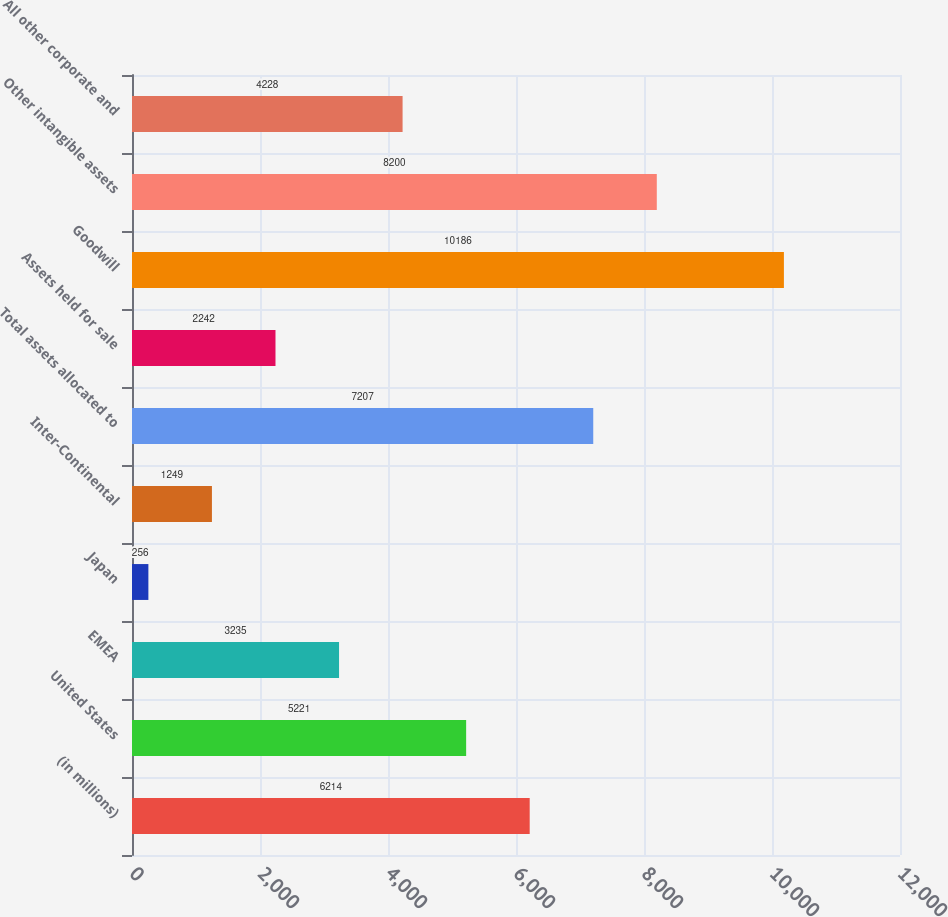Convert chart to OTSL. <chart><loc_0><loc_0><loc_500><loc_500><bar_chart><fcel>(in millions)<fcel>United States<fcel>EMEA<fcel>Japan<fcel>Inter-Continental<fcel>Total assets allocated to<fcel>Assets held for sale<fcel>Goodwill<fcel>Other intangible assets<fcel>All other corporate and<nl><fcel>6214<fcel>5221<fcel>3235<fcel>256<fcel>1249<fcel>7207<fcel>2242<fcel>10186<fcel>8200<fcel>4228<nl></chart> 